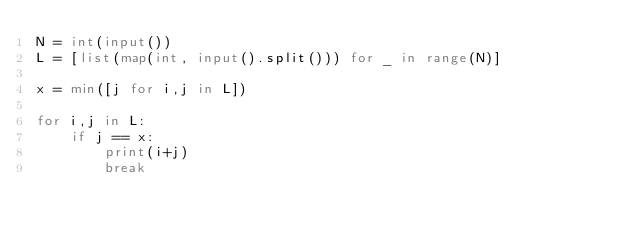<code> <loc_0><loc_0><loc_500><loc_500><_Python_>N = int(input())
L = [list(map(int, input().split())) for _ in range(N)]

x = min([j for i,j in L])

for i,j in L:
    if j == x:
        print(i+j)
        break</code> 